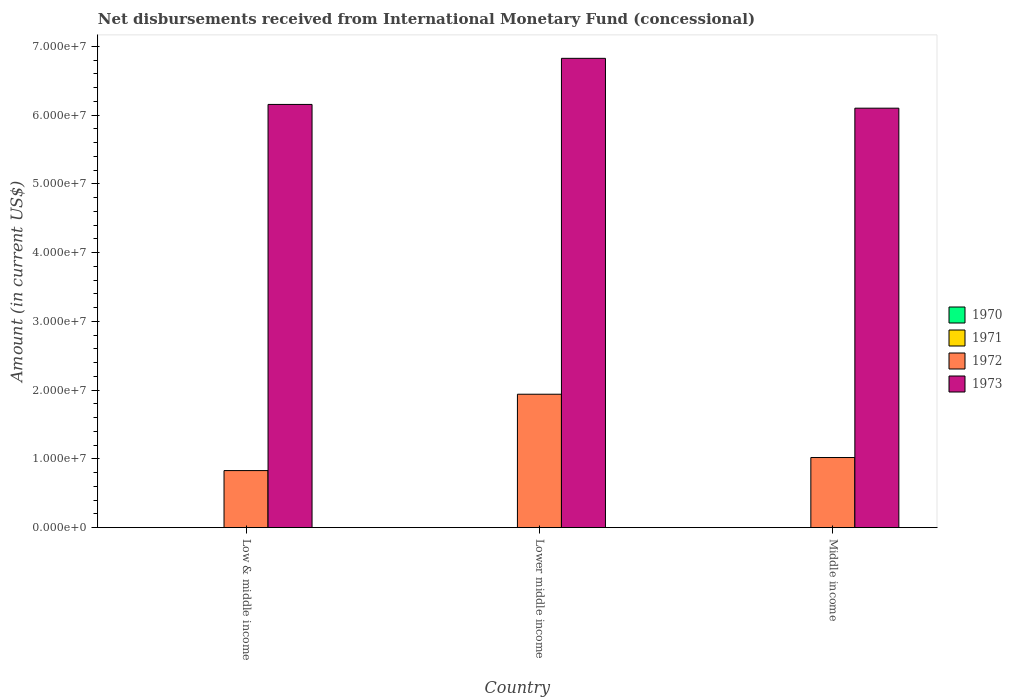How many different coloured bars are there?
Offer a very short reply. 2. How many groups of bars are there?
Provide a succinct answer. 3. Are the number of bars on each tick of the X-axis equal?
Offer a terse response. Yes. How many bars are there on the 1st tick from the left?
Ensure brevity in your answer.  2. How many bars are there on the 1st tick from the right?
Your response must be concise. 2. In how many cases, is the number of bars for a given country not equal to the number of legend labels?
Offer a terse response. 3. What is the amount of disbursements received from International Monetary Fund in 1973 in Low & middle income?
Your response must be concise. 6.16e+07. Across all countries, what is the maximum amount of disbursements received from International Monetary Fund in 1972?
Make the answer very short. 1.94e+07. In which country was the amount of disbursements received from International Monetary Fund in 1973 maximum?
Your answer should be very brief. Lower middle income. What is the total amount of disbursements received from International Monetary Fund in 1973 in the graph?
Ensure brevity in your answer.  1.91e+08. What is the difference between the amount of disbursements received from International Monetary Fund in 1973 in Lower middle income and that in Middle income?
Keep it short and to the point. 7.25e+06. What is the difference between the amount of disbursements received from International Monetary Fund in 1970 in Low & middle income and the amount of disbursements received from International Monetary Fund in 1973 in Middle income?
Your answer should be very brief. -6.10e+07. What is the average amount of disbursements received from International Monetary Fund in 1970 per country?
Offer a very short reply. 0. What is the difference between the amount of disbursements received from International Monetary Fund of/in 1972 and amount of disbursements received from International Monetary Fund of/in 1973 in Low & middle income?
Provide a short and direct response. -5.33e+07. In how many countries, is the amount of disbursements received from International Monetary Fund in 1973 greater than 18000000 US$?
Give a very brief answer. 3. What is the ratio of the amount of disbursements received from International Monetary Fund in 1972 in Low & middle income to that in Middle income?
Your response must be concise. 0.81. Is the amount of disbursements received from International Monetary Fund in 1973 in Low & middle income less than that in Lower middle income?
Offer a terse response. Yes. Is the difference between the amount of disbursements received from International Monetary Fund in 1972 in Low & middle income and Middle income greater than the difference between the amount of disbursements received from International Monetary Fund in 1973 in Low & middle income and Middle income?
Your response must be concise. No. What is the difference between the highest and the second highest amount of disbursements received from International Monetary Fund in 1972?
Keep it short and to the point. 9.21e+06. What is the difference between the highest and the lowest amount of disbursements received from International Monetary Fund in 1973?
Your answer should be compact. 7.25e+06. In how many countries, is the amount of disbursements received from International Monetary Fund in 1972 greater than the average amount of disbursements received from International Monetary Fund in 1972 taken over all countries?
Provide a short and direct response. 1. Is the sum of the amount of disbursements received from International Monetary Fund in 1972 in Lower middle income and Middle income greater than the maximum amount of disbursements received from International Monetary Fund in 1970 across all countries?
Provide a short and direct response. Yes. Is it the case that in every country, the sum of the amount of disbursements received from International Monetary Fund in 1970 and amount of disbursements received from International Monetary Fund in 1972 is greater than the sum of amount of disbursements received from International Monetary Fund in 1973 and amount of disbursements received from International Monetary Fund in 1971?
Offer a terse response. No. Is it the case that in every country, the sum of the amount of disbursements received from International Monetary Fund in 1970 and amount of disbursements received from International Monetary Fund in 1971 is greater than the amount of disbursements received from International Monetary Fund in 1972?
Keep it short and to the point. No. Are all the bars in the graph horizontal?
Ensure brevity in your answer.  No. Are the values on the major ticks of Y-axis written in scientific E-notation?
Your answer should be very brief. Yes. Where does the legend appear in the graph?
Your answer should be very brief. Center right. What is the title of the graph?
Keep it short and to the point. Net disbursements received from International Monetary Fund (concessional). Does "2006" appear as one of the legend labels in the graph?
Your answer should be compact. No. What is the Amount (in current US$) of 1971 in Low & middle income?
Make the answer very short. 0. What is the Amount (in current US$) in 1972 in Low & middle income?
Your answer should be compact. 8.30e+06. What is the Amount (in current US$) of 1973 in Low & middle income?
Your response must be concise. 6.16e+07. What is the Amount (in current US$) of 1971 in Lower middle income?
Offer a terse response. 0. What is the Amount (in current US$) of 1972 in Lower middle income?
Your answer should be very brief. 1.94e+07. What is the Amount (in current US$) of 1973 in Lower middle income?
Offer a very short reply. 6.83e+07. What is the Amount (in current US$) of 1970 in Middle income?
Keep it short and to the point. 0. What is the Amount (in current US$) in 1972 in Middle income?
Provide a short and direct response. 1.02e+07. What is the Amount (in current US$) of 1973 in Middle income?
Make the answer very short. 6.10e+07. Across all countries, what is the maximum Amount (in current US$) in 1972?
Your answer should be compact. 1.94e+07. Across all countries, what is the maximum Amount (in current US$) of 1973?
Provide a short and direct response. 6.83e+07. Across all countries, what is the minimum Amount (in current US$) of 1972?
Keep it short and to the point. 8.30e+06. Across all countries, what is the minimum Amount (in current US$) in 1973?
Offer a terse response. 6.10e+07. What is the total Amount (in current US$) of 1970 in the graph?
Give a very brief answer. 0. What is the total Amount (in current US$) in 1972 in the graph?
Your response must be concise. 3.79e+07. What is the total Amount (in current US$) of 1973 in the graph?
Your response must be concise. 1.91e+08. What is the difference between the Amount (in current US$) in 1972 in Low & middle income and that in Lower middle income?
Make the answer very short. -1.11e+07. What is the difference between the Amount (in current US$) of 1973 in Low & middle income and that in Lower middle income?
Offer a very short reply. -6.70e+06. What is the difference between the Amount (in current US$) of 1972 in Low & middle income and that in Middle income?
Make the answer very short. -1.90e+06. What is the difference between the Amount (in current US$) in 1973 in Low & middle income and that in Middle income?
Offer a terse response. 5.46e+05. What is the difference between the Amount (in current US$) of 1972 in Lower middle income and that in Middle income?
Provide a succinct answer. 9.21e+06. What is the difference between the Amount (in current US$) in 1973 in Lower middle income and that in Middle income?
Make the answer very short. 7.25e+06. What is the difference between the Amount (in current US$) of 1972 in Low & middle income and the Amount (in current US$) of 1973 in Lower middle income?
Your response must be concise. -6.00e+07. What is the difference between the Amount (in current US$) in 1972 in Low & middle income and the Amount (in current US$) in 1973 in Middle income?
Ensure brevity in your answer.  -5.27e+07. What is the difference between the Amount (in current US$) in 1972 in Lower middle income and the Amount (in current US$) in 1973 in Middle income?
Ensure brevity in your answer.  -4.16e+07. What is the average Amount (in current US$) of 1970 per country?
Keep it short and to the point. 0. What is the average Amount (in current US$) in 1971 per country?
Provide a short and direct response. 0. What is the average Amount (in current US$) of 1972 per country?
Ensure brevity in your answer.  1.26e+07. What is the average Amount (in current US$) of 1973 per country?
Make the answer very short. 6.36e+07. What is the difference between the Amount (in current US$) in 1972 and Amount (in current US$) in 1973 in Low & middle income?
Your answer should be compact. -5.33e+07. What is the difference between the Amount (in current US$) in 1972 and Amount (in current US$) in 1973 in Lower middle income?
Your answer should be compact. -4.89e+07. What is the difference between the Amount (in current US$) of 1972 and Amount (in current US$) of 1973 in Middle income?
Your answer should be compact. -5.08e+07. What is the ratio of the Amount (in current US$) of 1972 in Low & middle income to that in Lower middle income?
Your answer should be very brief. 0.43. What is the ratio of the Amount (in current US$) in 1973 in Low & middle income to that in Lower middle income?
Provide a short and direct response. 0.9. What is the ratio of the Amount (in current US$) in 1972 in Low & middle income to that in Middle income?
Your answer should be very brief. 0.81. What is the ratio of the Amount (in current US$) in 1972 in Lower middle income to that in Middle income?
Offer a terse response. 1.9. What is the ratio of the Amount (in current US$) of 1973 in Lower middle income to that in Middle income?
Your response must be concise. 1.12. What is the difference between the highest and the second highest Amount (in current US$) of 1972?
Make the answer very short. 9.21e+06. What is the difference between the highest and the second highest Amount (in current US$) of 1973?
Provide a succinct answer. 6.70e+06. What is the difference between the highest and the lowest Amount (in current US$) in 1972?
Give a very brief answer. 1.11e+07. What is the difference between the highest and the lowest Amount (in current US$) of 1973?
Keep it short and to the point. 7.25e+06. 